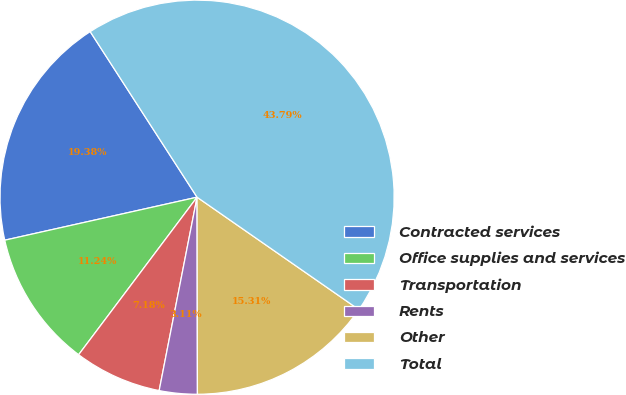<chart> <loc_0><loc_0><loc_500><loc_500><pie_chart><fcel>Contracted services<fcel>Office supplies and services<fcel>Transportation<fcel>Rents<fcel>Other<fcel>Total<nl><fcel>19.38%<fcel>11.24%<fcel>7.18%<fcel>3.11%<fcel>15.31%<fcel>43.79%<nl></chart> 